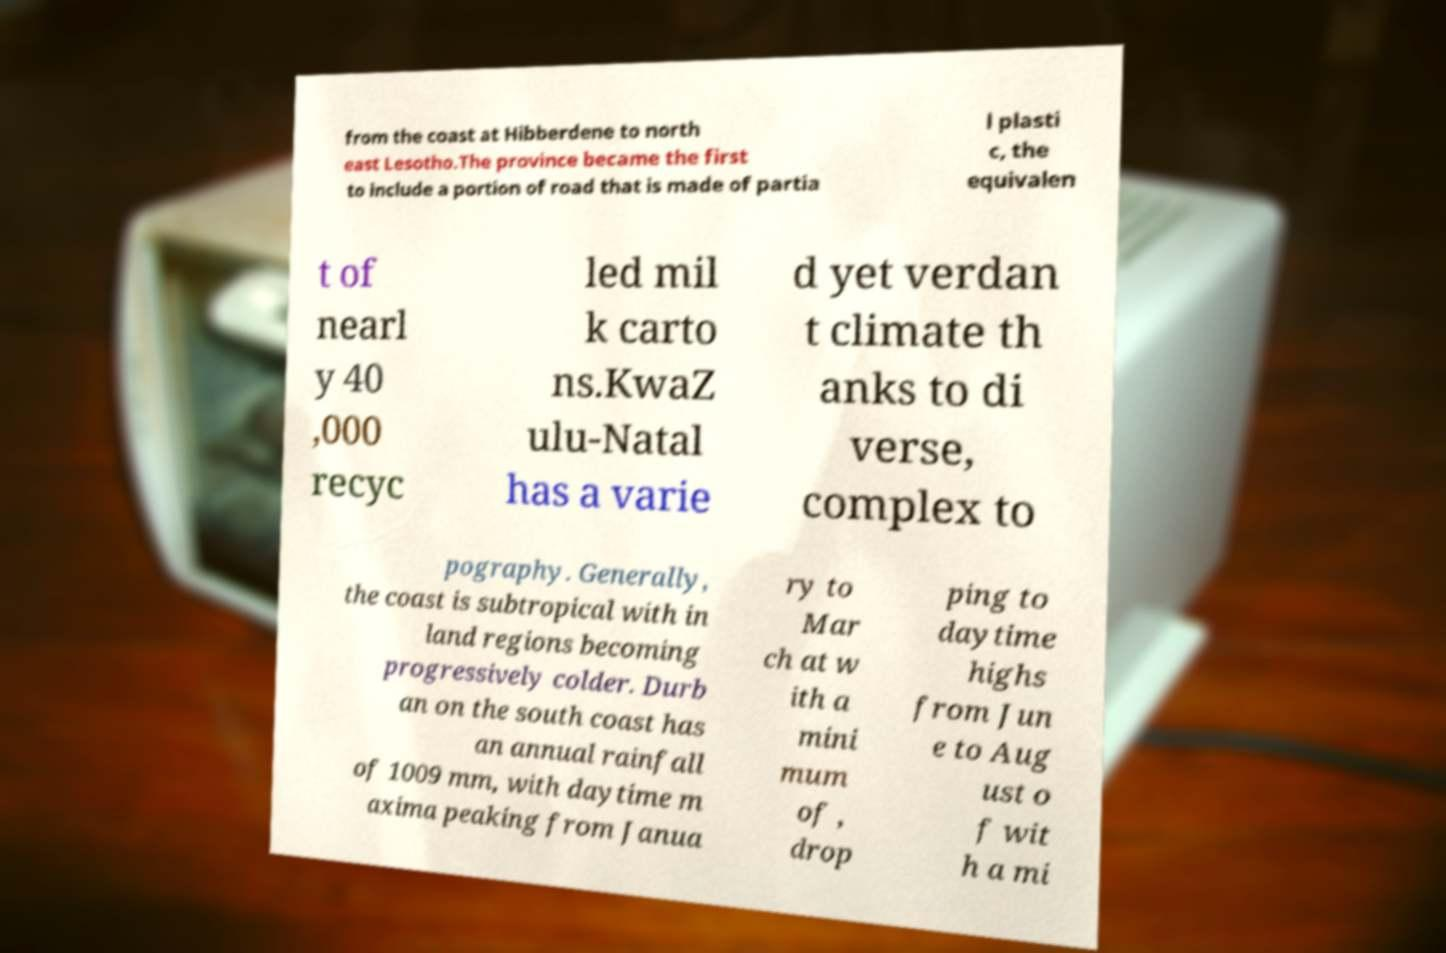What messages or text are displayed in this image? I need them in a readable, typed format. from the coast at Hibberdene to north east Lesotho.The province became the first to include a portion of road that is made of partia l plasti c, the equivalen t of nearl y 40 ,000 recyc led mil k carto ns.KwaZ ulu-Natal has a varie d yet verdan t climate th anks to di verse, complex to pography. Generally, the coast is subtropical with in land regions becoming progressively colder. Durb an on the south coast has an annual rainfall of 1009 mm, with daytime m axima peaking from Janua ry to Mar ch at w ith a mini mum of , drop ping to daytime highs from Jun e to Aug ust o f wit h a mi 